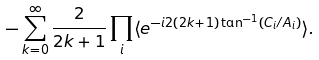<formula> <loc_0><loc_0><loc_500><loc_500>- \sum _ { k = 0 } ^ { \infty } \frac { 2 } { 2 k + 1 } \prod _ { i } \langle e ^ { - i 2 ( 2 k + 1 ) \tan ^ { - 1 } ( C _ { i } / A _ { i } ) } \rangle .</formula> 